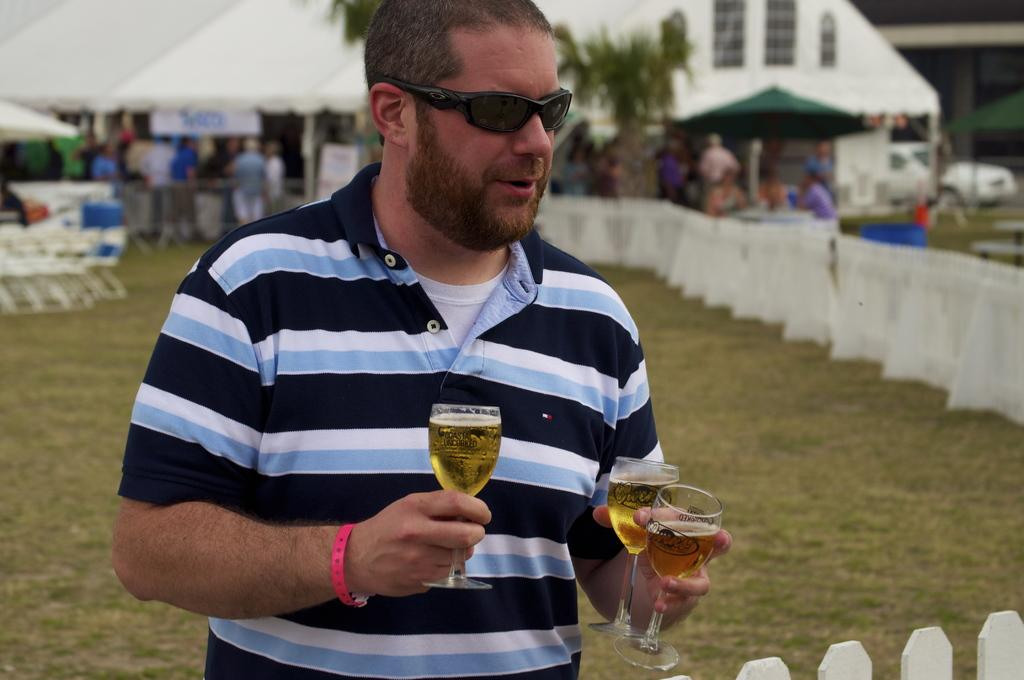What is the main subject in the center of the image? There is a person standing in the center of the image. What is the person holding in his hand? The person is holding wine glasses in his hand. What can be seen in the background on the right side of the image? There is a house in the background on the right side of the image. Are there any other people visible in the image? Yes, there are a few people in the background on the left side of the image. What type of mint is growing on the ground in the image? There is no mint or ground visible in the image; it primarily features a person holding wine glasses and a background with a house and other people. 